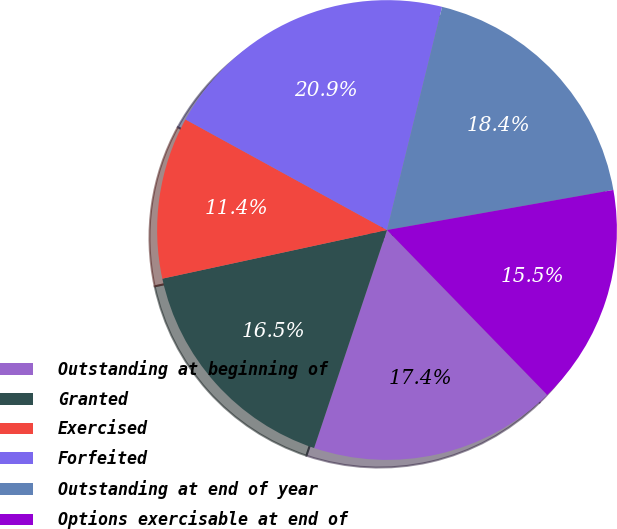Convert chart. <chart><loc_0><loc_0><loc_500><loc_500><pie_chart><fcel>Outstanding at beginning of<fcel>Granted<fcel>Exercised<fcel>Forfeited<fcel>Outstanding at end of year<fcel>Options exercisable at end of<nl><fcel>17.41%<fcel>16.47%<fcel>11.38%<fcel>20.87%<fcel>18.36%<fcel>15.52%<nl></chart> 